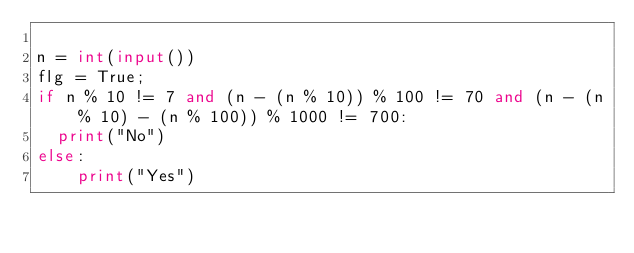<code> <loc_0><loc_0><loc_500><loc_500><_Python_>
n = int(input())
flg = True;
if n % 10 != 7 and (n - (n % 10)) % 100 != 70 and (n - (n % 10) - (n % 100)) % 1000 != 700:
  print("No")
else:
    print("Yes")</code> 